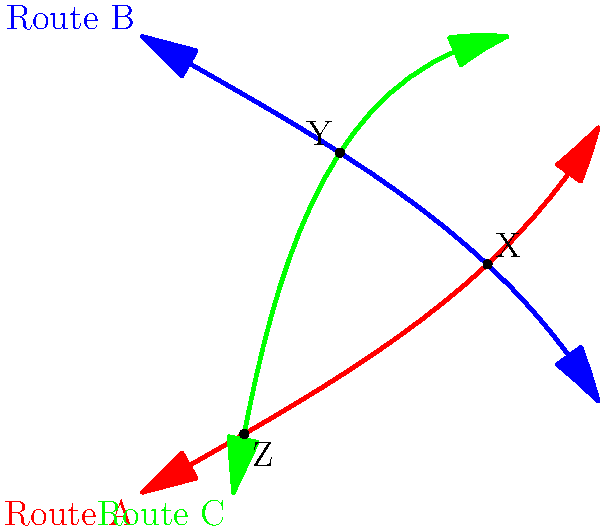In this visual representation of overlapping historical trade routes, how many unique intersection points are there between the three routes, and what potential significance might these intersections hold for cultural exchange and economic activity in the past? To answer this question, we need to analyze the diagram step-by-step:

1. Identify the routes:
   - Route A (red)
   - Route B (blue)
   - Route C (green)

2. Locate the intersection points:
   - Point X: intersection of Route A and Route B
   - Point Y: intersection of Route B and Route C
   - Point Z: intersection of Route A and Route C

3. Count the unique intersection points:
   There are 3 unique intersection points (X, Y, and Z).

4. Consider the significance of these intersections:
   a) Cultural exchange: These points represent locations where traders from different routes would meet, potentially exchanging not just goods but also ideas, languages, and cultural practices.
   
   b) Economic activity: Intersection points often developed into important trading hubs or cities due to the convergence of multiple trade routes, fostering economic growth and diversification.
   
   c) Knowledge transfer: These points could have been crucial for the spread of technological innovations, scientific knowledge, and religious ideas across different regions.
   
   d) Political importance: Cities at these intersections might have gained strategic importance, potentially becoming centers of political power or targets for conquest.
   
   e) Demographic changes: The movement of people along these routes and their settlement at intersection points could have led to diverse, multicultural populations in these areas.
Answer: 3 intersections; hubs for cultural, economic, and knowledge exchange 